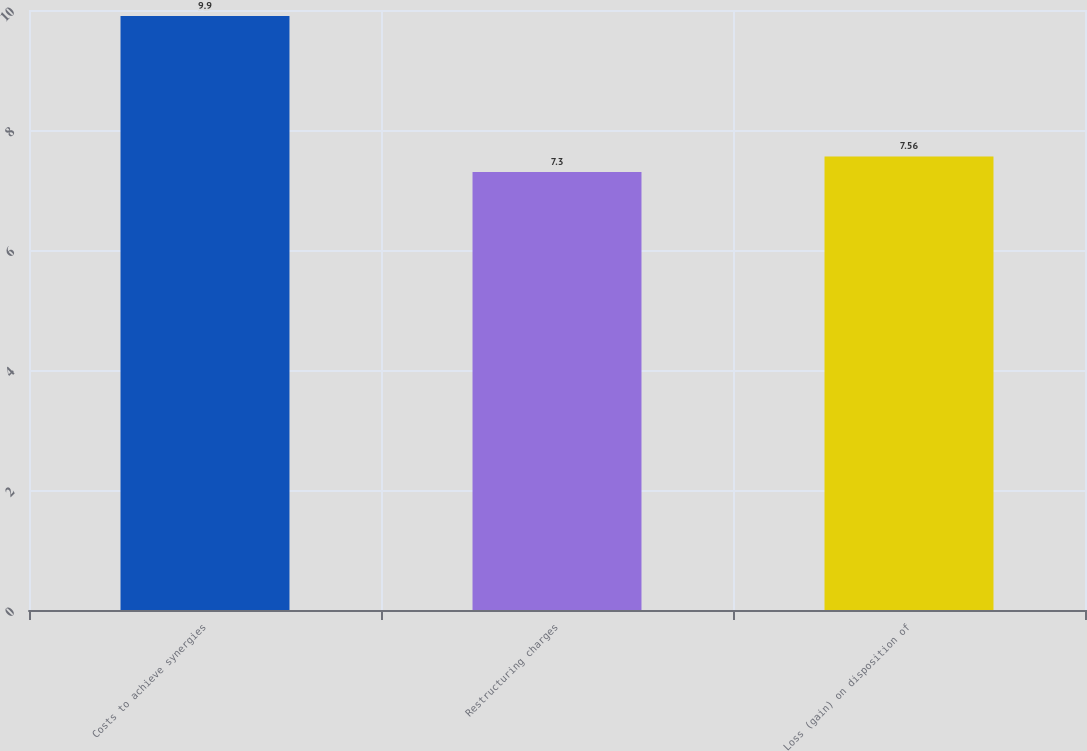Convert chart. <chart><loc_0><loc_0><loc_500><loc_500><bar_chart><fcel>Costs to achieve synergies<fcel>Restructuring charges<fcel>Loss (gain) on disposition of<nl><fcel>9.9<fcel>7.3<fcel>7.56<nl></chart> 